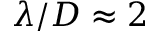Convert formula to latex. <formula><loc_0><loc_0><loc_500><loc_500>\lambda / D \approx 2</formula> 